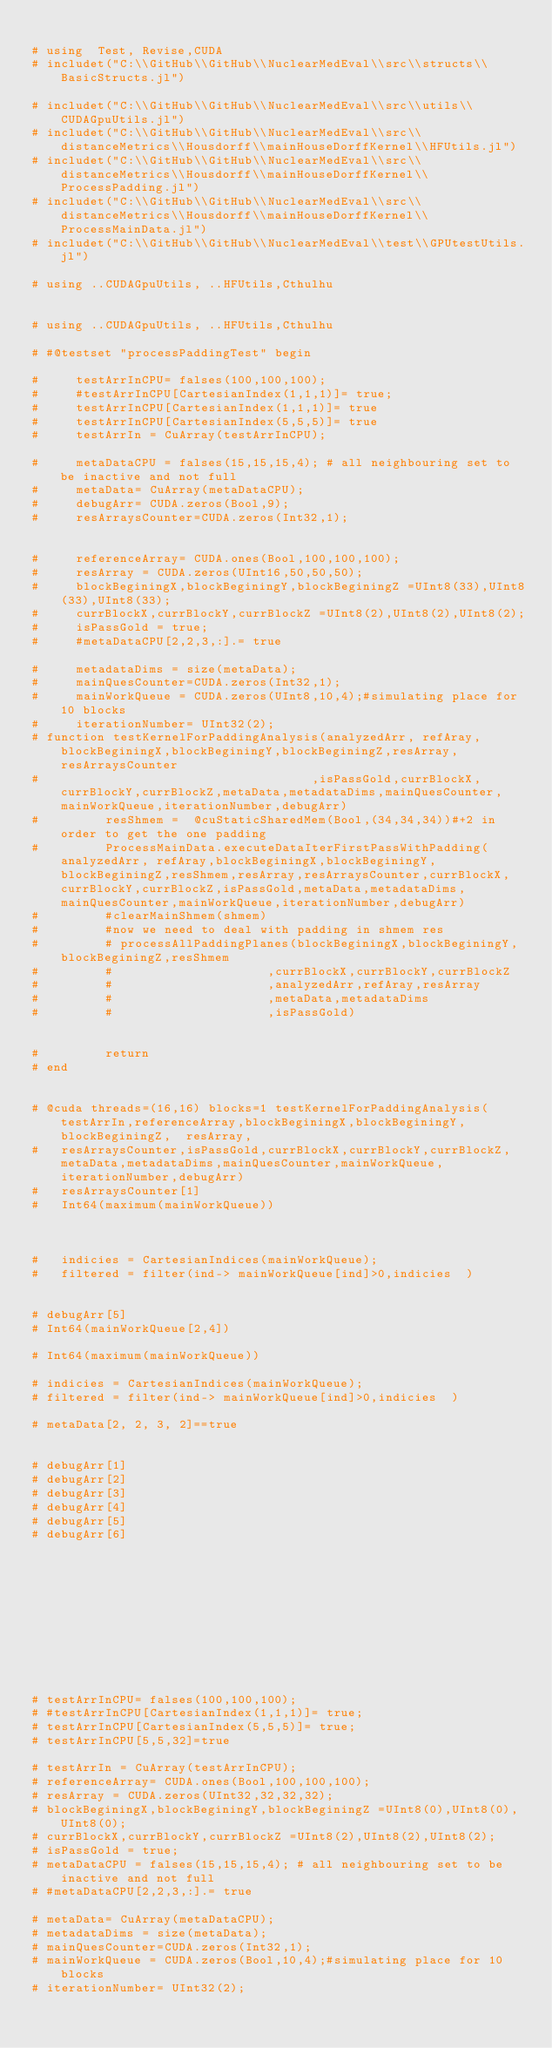<code> <loc_0><loc_0><loc_500><loc_500><_Julia_>
# using  Test, Revise,CUDA 
# includet("C:\\GitHub\\GitHub\\NuclearMedEval\\src\\structs\\BasicStructs.jl")

# includet("C:\\GitHub\\GitHub\\NuclearMedEval\\src\\utils\\CUDAGpuUtils.jl")
# includet("C:\\GitHub\\GitHub\\NuclearMedEval\\src\\distanceMetrics\\Housdorff\\mainHouseDorffKernel\\HFUtils.jl")
# includet("C:\\GitHub\\GitHub\\NuclearMedEval\\src\\distanceMetrics\\Housdorff\\mainHouseDorffKernel\\ProcessPadding.jl")
# includet("C:\\GitHub\\GitHub\\NuclearMedEval\\src\\distanceMetrics\\Housdorff\\mainHouseDorffKernel\\ProcessMainData.jl")
# includet("C:\\GitHub\\GitHub\\NuclearMedEval\\test\\GPUtestUtils.jl")

# using ..CUDAGpuUtils, ..HFUtils,Cthulhu


# using ..CUDAGpuUtils, ..HFUtils,Cthulhu

# #@testset "processPaddingTest" begin 

#     testArrInCPU= falses(100,100,100);
#     #testArrInCPU[CartesianIndex(1,1,1)]= true;
#     testArrInCPU[CartesianIndex(1,1,1)]= true
#     testArrInCPU[CartesianIndex(5,5,5)]= true
#     testArrIn = CuArray(testArrInCPU);

#     metaDataCPU = falses(15,15,15,4); # all neighbouring set to be inactive and not full
#     metaData= CuArray(metaDataCPU);
#     debugArr= CUDA.zeros(Bool,9);
#     resArraysCounter=CUDA.zeros(Int32,1);


#     referenceArray= CUDA.ones(Bool,100,100,100);
#     resArray = CUDA.zeros(UInt16,50,50,50);
#     blockBeginingX,blockBeginingY,blockBeginingZ =UInt8(33),UInt8(33),UInt8(33);
#     currBlockX,currBlockY,currBlockZ =UInt8(2),UInt8(2),UInt8(2);
#     isPassGold = true;
#     #metaDataCPU[2,2,3,:].= true

#     metadataDims = size(metaData);
#     mainQuesCounter=CUDA.zeros(Int32,1);
#     mainWorkQueue = CUDA.zeros(UInt8,10,4);#simulating place for 10 blocks
#     iterationNumber= UInt32(2);
# function testKernelForPaddingAnalysis(analyzedArr, refAray,blockBeginingX,blockBeginingY,blockBeginingZ,resArray,resArraysCounter
#                                     ,isPassGold,currBlockX,currBlockY,currBlockZ,metaData,metadataDims,mainQuesCounter,mainWorkQueue,iterationNumber,debugArr)
#         resShmem =  @cuStaticSharedMem(Bool,(34,34,34))#+2 in order to get the one padding 
#         ProcessMainData.executeDataIterFirstPassWithPadding(analyzedArr, refAray,blockBeginingX,blockBeginingY,blockBeginingZ,resShmem,resArray,resArraysCounter,currBlockX,currBlockY,currBlockZ,isPassGold,metaData,metadataDims,mainQuesCounter,mainWorkQueue,iterationNumber,debugArr)
#         #clearMainShmem(shmem)
#         #now we need to deal with padding in shmem res
#         # processAllPaddingPlanes(blockBeginingX,blockBeginingY,blockBeginingZ,resShmem
#         #                     ,currBlockX,currBlockY,currBlockZ
#         #                     ,analyzedArr,refAray,resArray
#         #                     ,metaData,metadataDims
#         #                     ,isPassGold)


#         return
# end


# @cuda threads=(16,16) blocks=1 testKernelForPaddingAnalysis(testArrIn,referenceArray,blockBeginingX,blockBeginingY,blockBeginingZ,  resArray,
#   resArraysCounter,isPassGold,currBlockX,currBlockY,currBlockZ,metaData,metadataDims,mainQuesCounter,mainWorkQueue,iterationNumber,debugArr) 
#   resArraysCounter[1]
#   Int64(maximum(mainWorkQueue))



#   indicies = CartesianIndices(mainWorkQueue);
#   filtered = filter(ind-> mainWorkQueue[ind]>0,indicies  )


# debugArr[5]
# Int64(mainWorkQueue[2,4])

# Int64(maximum(mainWorkQueue))

# indicies = CartesianIndices(mainWorkQueue);
# filtered = filter(ind-> mainWorkQueue[ind]>0,indicies  )

# metaData[2, 2, 3, 2]==true


# debugArr[1]
# debugArr[2]
# debugArr[3]
# debugArr[4]
# debugArr[5]
# debugArr[6]











# testArrInCPU= falses(100,100,100);
# #testArrInCPU[CartesianIndex(1,1,1)]= true;
# testArrInCPU[CartesianIndex(5,5,5)]= true;
# testArrInCPU[5,5,32]=true

# testArrIn = CuArray(testArrInCPU);
# referenceArray= CUDA.ones(Bool,100,100,100);
# resArray = CUDA.zeros(UInt32,32,32,32);
# blockBeginingX,blockBeginingY,blockBeginingZ =UInt8(0),UInt8(0),UInt8(0);
# currBlockX,currBlockY,currBlockZ =UInt8(2),UInt8(2),UInt8(2);
# isPassGold = true;
# metaDataCPU = falses(15,15,15,4); # all neighbouring set to be inactive and not full
# #metaDataCPU[2,2,3,:].= true

# metaData= CuArray(metaDataCPU);
# metadataDims = size(metaData);
# mainQuesCounter=CUDA.zeros(Int32,1);
# mainWorkQueue = CUDA.zeros(Bool,10,4);#simulating place for 10 blocks
# iterationNumber= UInt32(2);
</code> 